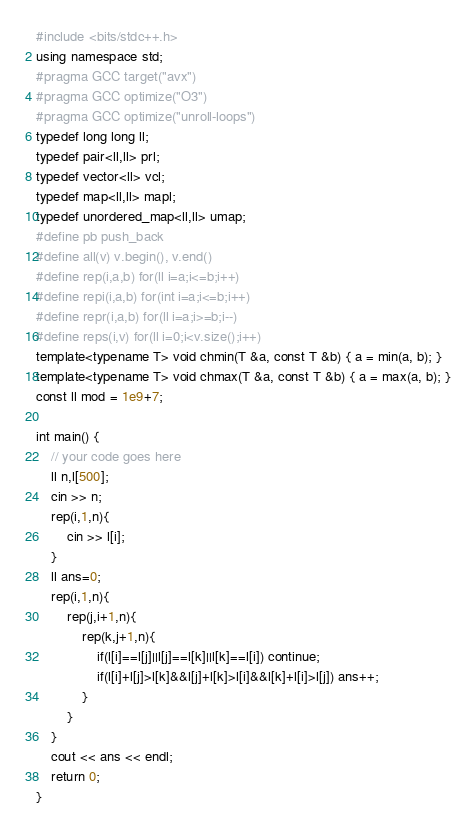Convert code to text. <code><loc_0><loc_0><loc_500><loc_500><_C++_>#include <bits/stdc++.h>
using namespace std;
#pragma GCC target("avx")
#pragma GCC optimize("O3")
#pragma GCC optimize("unroll-loops")
typedef long long ll;
typedef pair<ll,ll> prl;
typedef vector<ll> vcl;
typedef map<ll,ll> mapl;
typedef unordered_map<ll,ll> umap;
#define pb push_back
#define all(v) v.begin(), v.end()
#define rep(i,a,b) for(ll i=a;i<=b;i++)
#define repi(i,a,b) for(int i=a;i<=b;i++)
#define repr(i,a,b) for(ll i=a;i>=b;i--)
#define reps(i,v) for(ll i=0;i<v.size();i++)
template<typename T> void chmin(T &a, const T &b) { a = min(a, b); }
template<typename T> void chmax(T &a, const T &b) { a = max(a, b); }
const ll mod = 1e9+7;

int main() {
    // your code goes here
    ll n,l[500];
    cin >> n;
    rep(i,1,n){
    	cin >> l[i];
    }
    ll ans=0;
    rep(i,1,n){
    	rep(j,i+1,n){
    		rep(k,j+1,n){
    			if(l[i]==l[j]||l[j]==l[k]||l[k]==l[i]) continue;
    			if(l[i]+l[j]>l[k]&&l[j]+l[k]>l[i]&&l[k]+l[i]>l[j]) ans++;
    		}
    	}
    }
    cout << ans << endl;
    return 0;
}</code> 